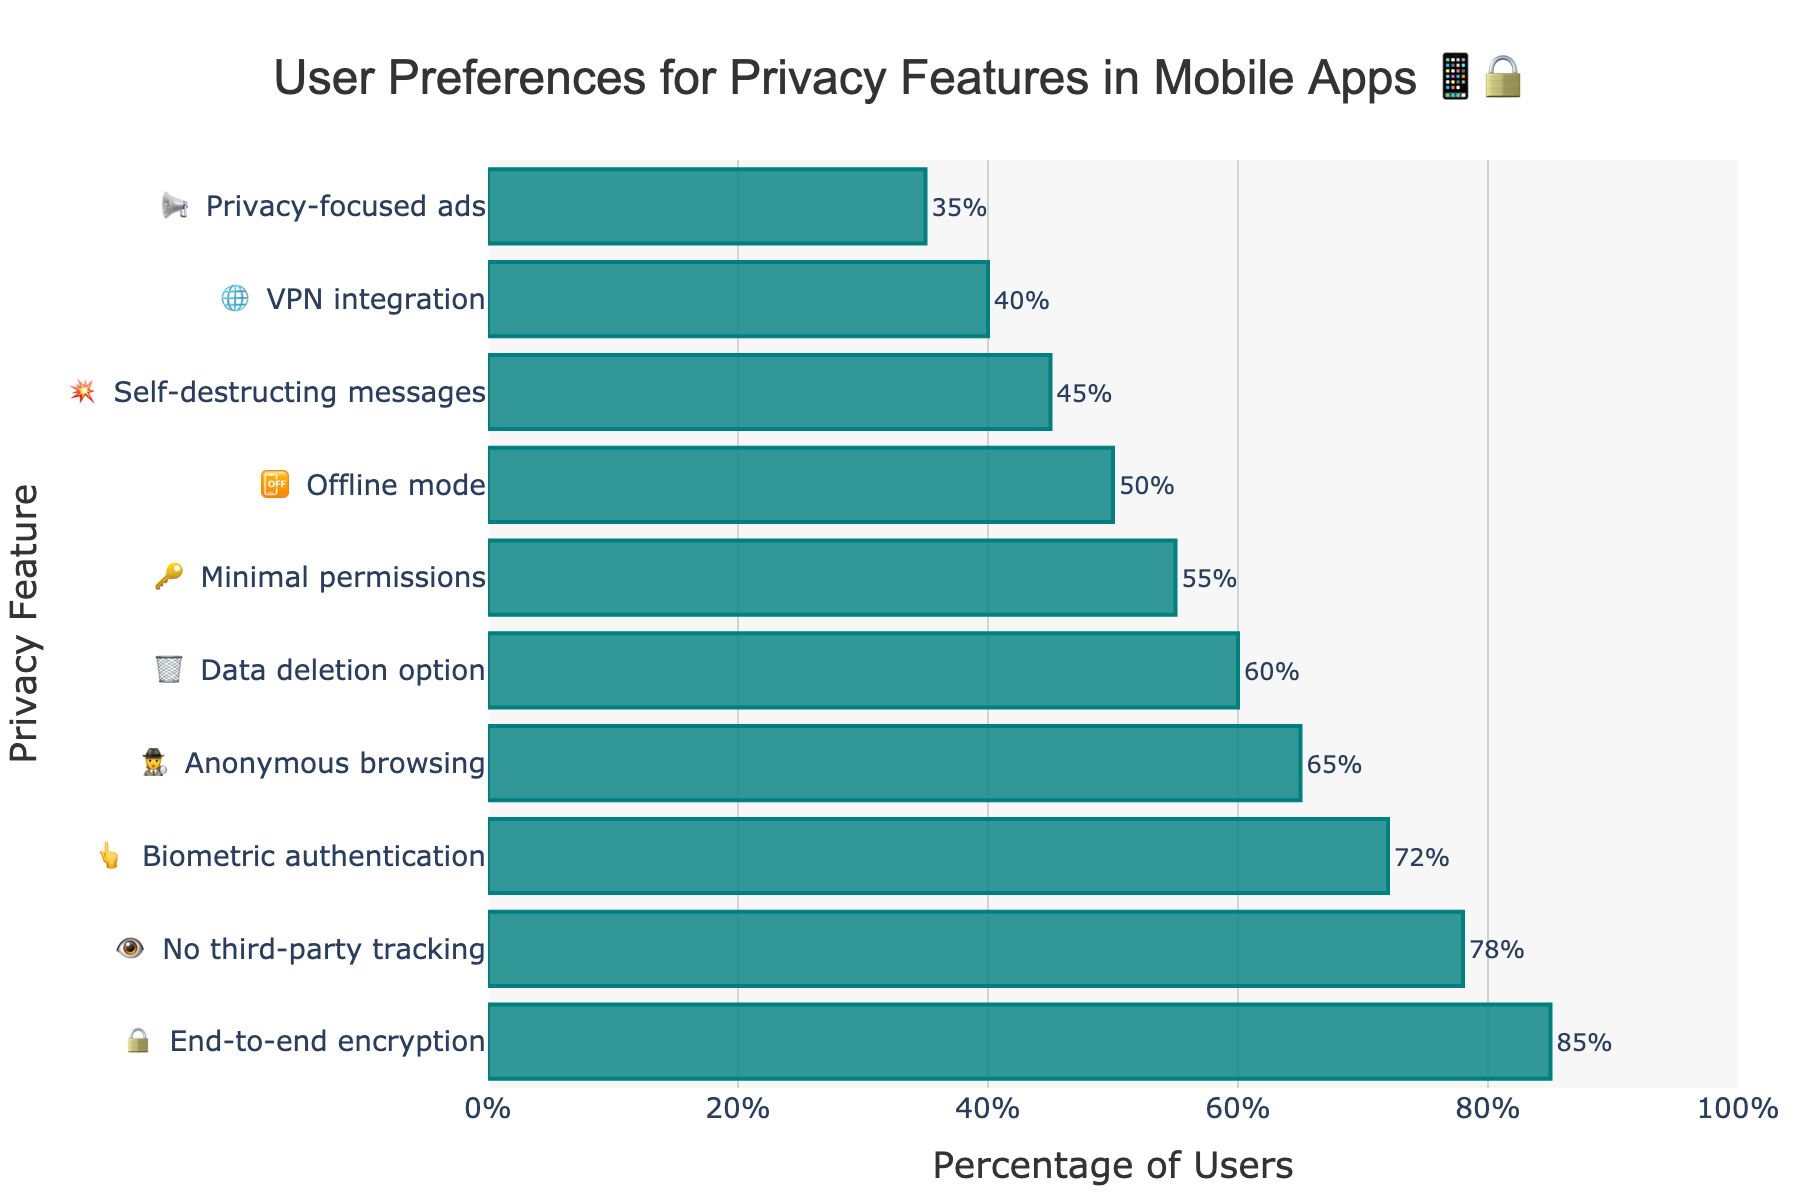What is the most preferred privacy feature among users? The highest bar in the chart represents the most preferred feature. The feature with the tallest bar is "End-to-end encryption" with a user preference of 85%.
Answer: End-to-end encryption Which privacy feature is preferred by the least percentage of users? The shortest bar in the chart represents the least preferred feature. The feature with the shortest bar is "Privacy-focused ads" with a user preference of 35%.
Answer: Privacy-focused ads How much higher is the preference for "No third-party tracking" compared to "Minimal permissions"? The bar for "No third-party tracking" shows 78%, and the bar for "Minimal permissions" shows 55%. The difference is 78% - 55% = 23%.
Answer: 23% What is the average user preference percentage for "Biometric authentication," "Anonymous browsing," and "Data deletion option"? The percentages are 72%, 65%, and 60%. Summing them up: 72% + 65% + 60% = 197%, and the average is 197% / 3 = 65.67%.
Answer: 65.67% What percentage of users prefer "Offline mode"? Look for the bar labeled "Offline mode." It shows 50% preference.
Answer: 50% Rank the top three privacy features preferred by users. Identify the three highest bars. They are "End-to-end encryption" (85%), "No third-party tracking" (78%), and "Biometric authentication" (72%).
Answer: 1. End-to-end encryption, 2. No third-party tracking, 3. Biometric authentication Is "VPN integration" more or less preferred than "Self-destructing messages"? Compare the heights of the bars for "VPN integration" (40%) and "Self-destructing messages" (45%). "VPN integration" has a lower preference.
Answer: Less What is the total user preference percentage for "No third-party tracking" and "Anonymous browsing"? Summing the percentages for "No third-party tracking" (78%) and "Anonymous browsing" (65%) gives 143%.
Answer: 143% Which feature has slightly more preference, "Data deletion option" or "Minimal permissions"? Compare the bars for "Data deletion option" (60%) and "Minimal permissions" (55%). "Data deletion option" has a slightly higher preference.
Answer: Data deletion option 